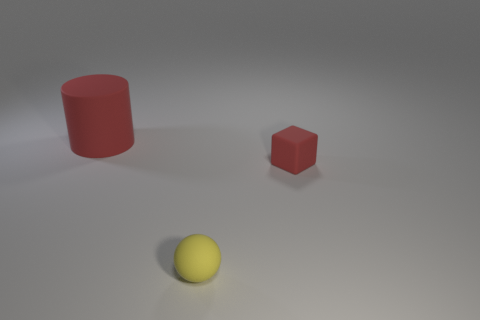Add 3 yellow rubber balls. How many objects exist? 6 Subtract all cubes. How many objects are left? 2 Subtract 1 cubes. How many cubes are left? 0 Add 3 small spheres. How many small spheres exist? 4 Subtract 0 purple cylinders. How many objects are left? 3 Subtract all blue balls. Subtract all green blocks. How many balls are left? 1 Subtract all big rubber cylinders. Subtract all cyan shiny cylinders. How many objects are left? 2 Add 1 small red things. How many small red things are left? 2 